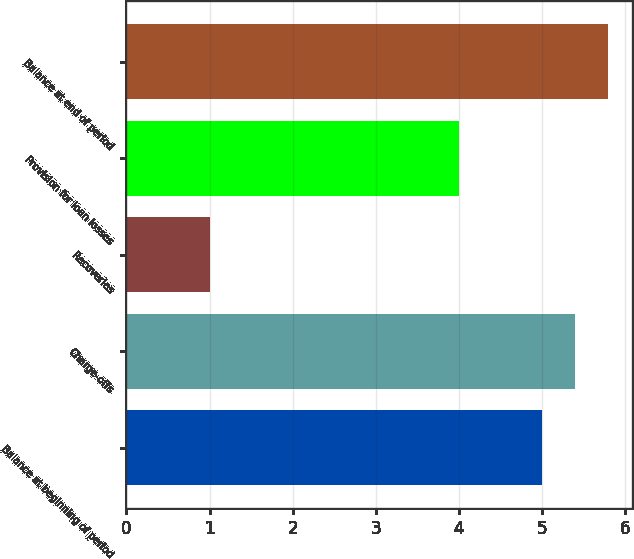<chart> <loc_0><loc_0><loc_500><loc_500><bar_chart><fcel>Balance at beginning of period<fcel>Charge-offs<fcel>Recoveries<fcel>Provision for loan losses<fcel>Balance at end of period<nl><fcel>5<fcel>5.4<fcel>1<fcel>4<fcel>5.8<nl></chart> 